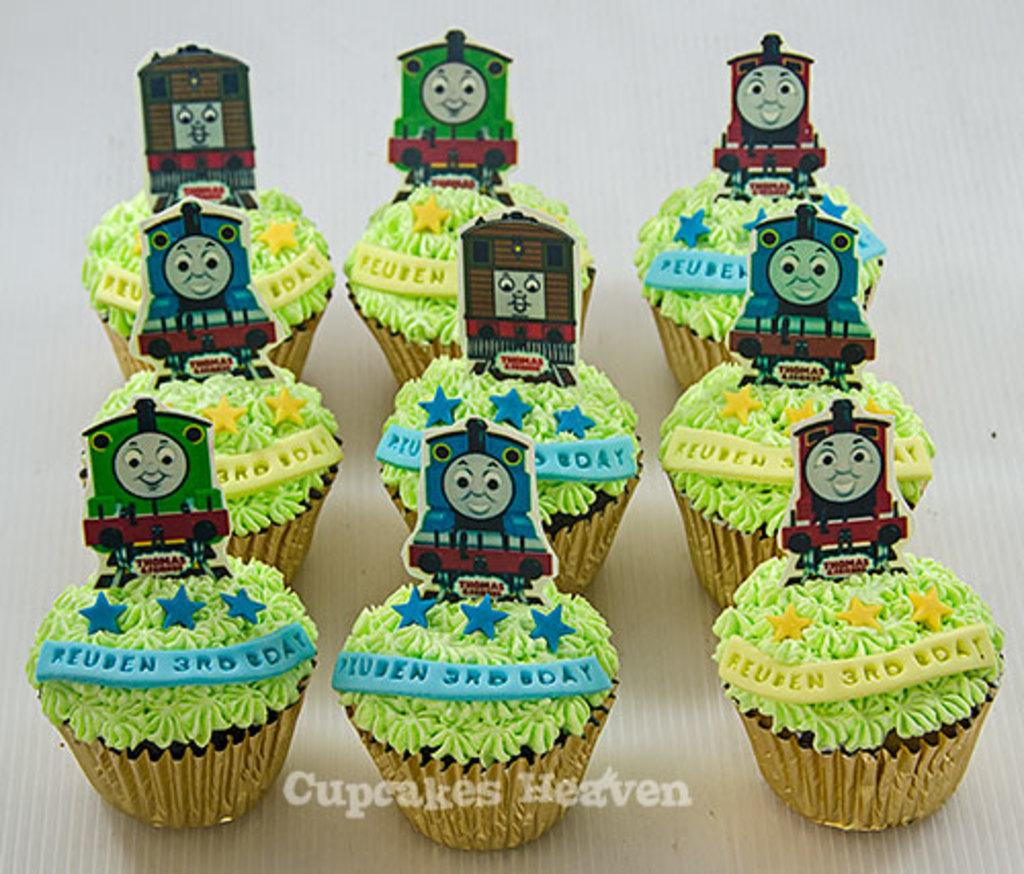What type of food can be seen in the foreground of the image? There are cupcakes in the foreground of the image. What else is present in the image besides the cupcakes? There are posters in the image. Can you describe the surface on which the posters are placed? The posters are placed on a white surface. How many pickles are visible on the posters in the image? There are no pickles present on the posters in the image. What event is being celebrated in the image? The provided facts do not mention any specific event or celebration, so we cannot determine what is being celebrated from the image alone. 